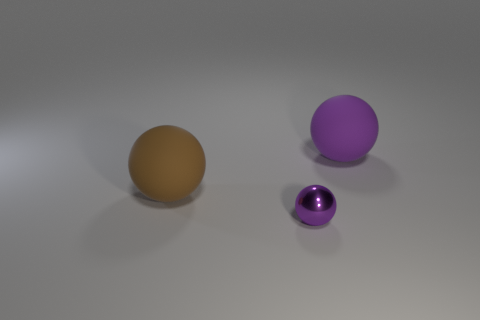Is there any other thing that is the same size as the purple shiny thing?
Make the answer very short. No. Does the purple thing that is on the right side of the small metallic ball have the same size as the rubber sphere that is on the left side of the purple metallic object?
Give a very brief answer. Yes. There is a ball that is to the right of the purple shiny sphere; how big is it?
Your response must be concise. Large. Is there another small metal object of the same color as the metal thing?
Your answer should be very brief. No. Are there any brown objects that are left of the big rubber object that is on the left side of the tiny metal thing?
Provide a short and direct response. No. There is a brown object; is it the same size as the object that is in front of the brown matte thing?
Offer a terse response. No. There is a big matte ball that is behind the brown rubber ball that is behind the tiny purple metallic thing; is there a purple metal sphere that is to the right of it?
Your response must be concise. No. There is a big thing right of the tiny purple object; what is it made of?
Provide a short and direct response. Rubber. Is the purple rubber thing the same size as the brown thing?
Your response must be concise. Yes. The thing that is both in front of the big purple sphere and right of the brown sphere is what color?
Ensure brevity in your answer.  Purple. 